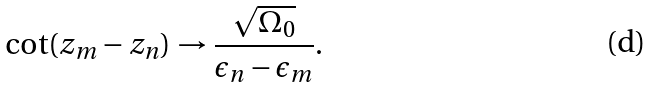Convert formula to latex. <formula><loc_0><loc_0><loc_500><loc_500>\cot ( z _ { m } - z _ { n } ) \rightarrow \frac { \sqrt { \Omega _ { 0 } } } { \epsilon _ { n } - \epsilon _ { m } } .</formula> 